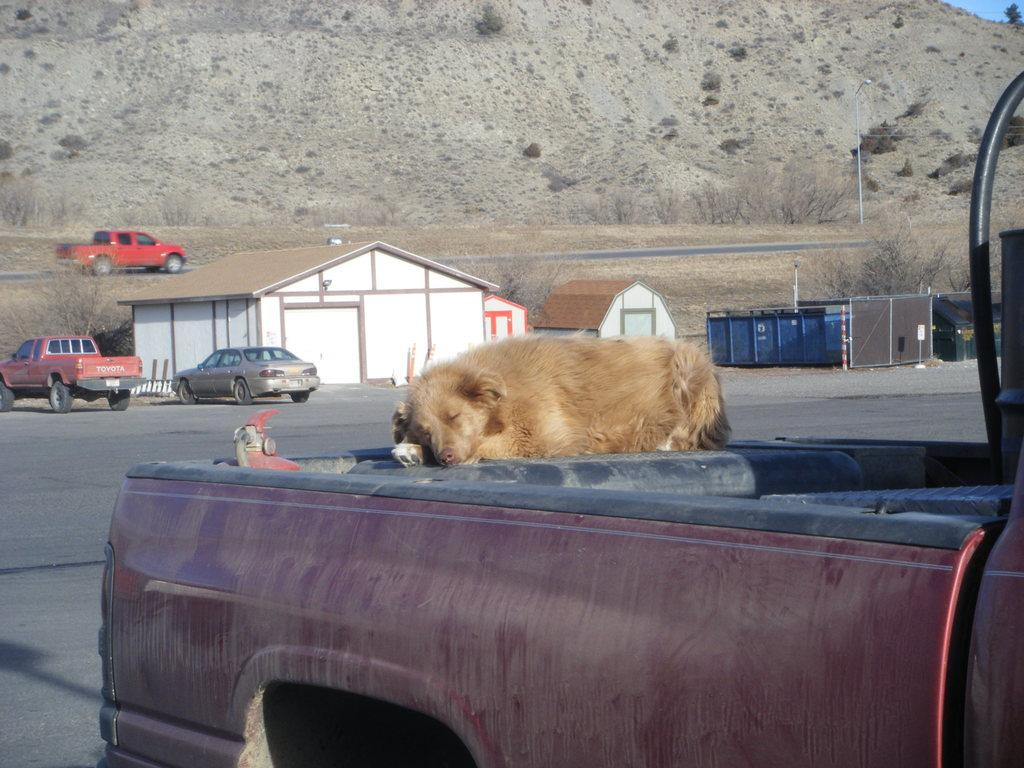What is the animal lying on in the image? The animal is lying on a vehicle in the image. What type of structures can be seen in the image? There are houses in the image. What else is present in the image besides the animal and houses? There are vehicles and grass in the image. What kind of terrain is visible in the image? There is a hill in the image. How many rings are visible on the animal's tail in the image? There are no rings visible on the animal's tail in the image, as the animal is not described as having a tail or rings. 